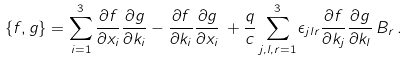Convert formula to latex. <formula><loc_0><loc_0><loc_500><loc_500>\left \{ f , g \right \} = \sum _ { i = 1 } ^ { 3 } \frac { \partial f } { \partial x _ { i } } \frac { \partial g } { \partial k _ { i } } - \frac { \partial f } { \partial k _ { i } } \frac { \partial g } { \partial x _ { i } } \, + \frac { q } { c } \sum _ { j , l , r = 1 } ^ { 3 } \epsilon _ { j l r } \frac { \partial f } { \partial k _ { j } } \frac { \partial g } { \partial k _ { l } } \, B _ { r } \, .</formula> 